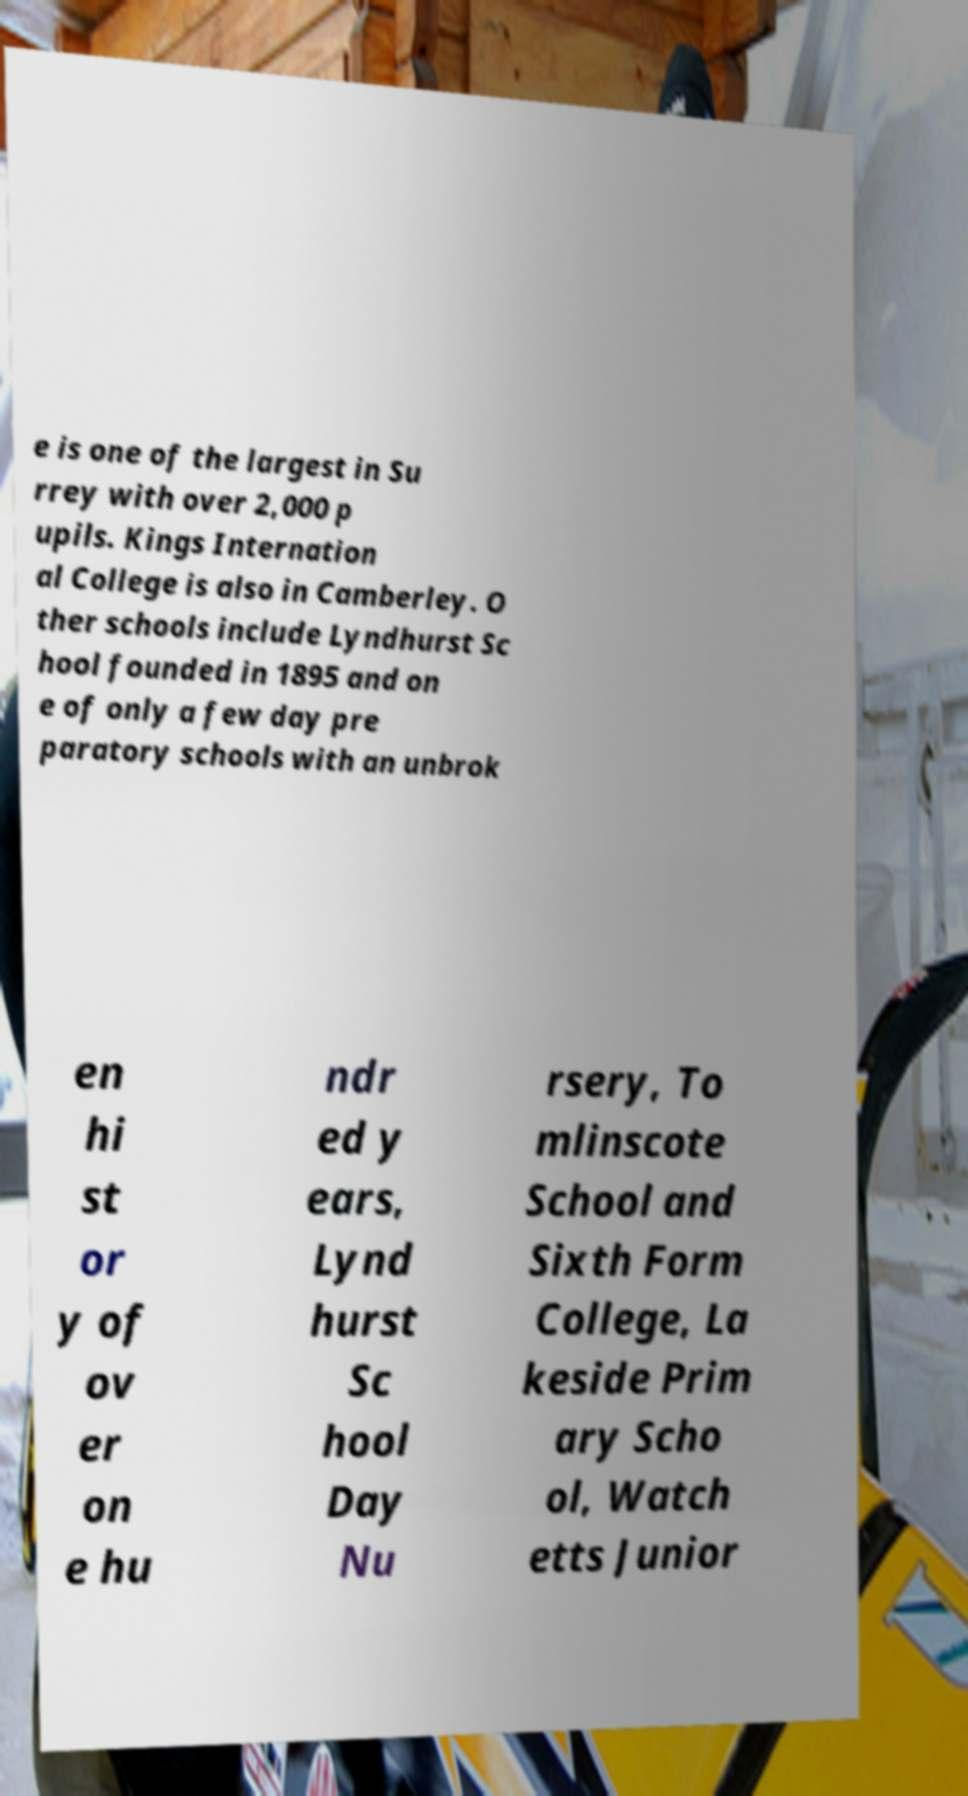Please read and relay the text visible in this image. What does it say? e is one of the largest in Su rrey with over 2,000 p upils. Kings Internation al College is also in Camberley. O ther schools include Lyndhurst Sc hool founded in 1895 and on e of only a few day pre paratory schools with an unbrok en hi st or y of ov er on e hu ndr ed y ears, Lynd hurst Sc hool Day Nu rsery, To mlinscote School and Sixth Form College, La keside Prim ary Scho ol, Watch etts Junior 